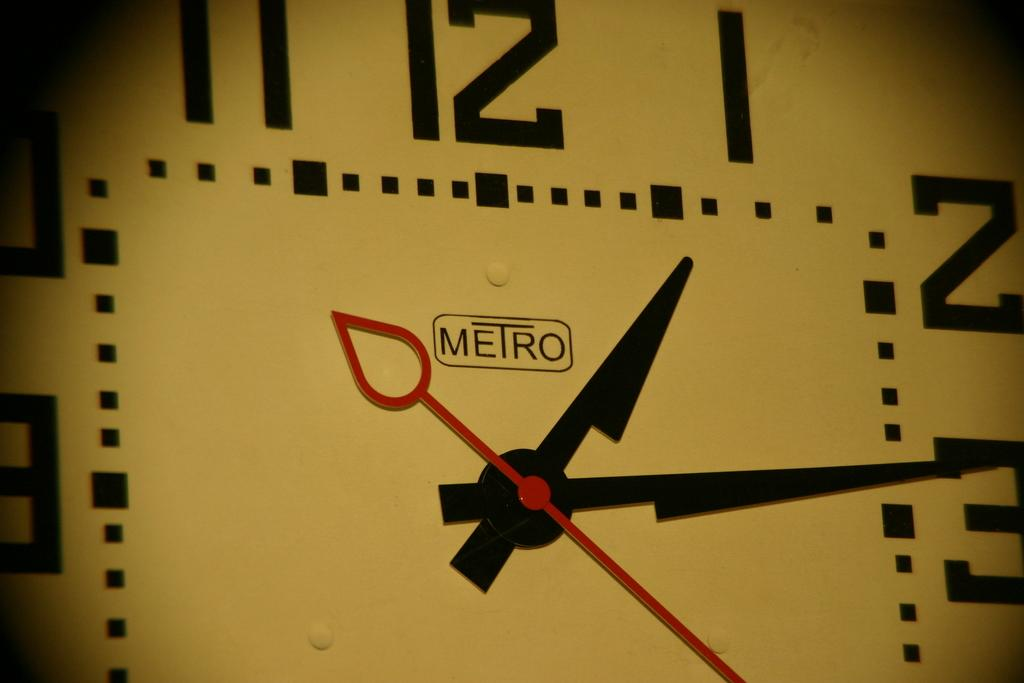<image>
Share a concise interpretation of the image provided. A Metro logo in the center of a clock below number 12. 